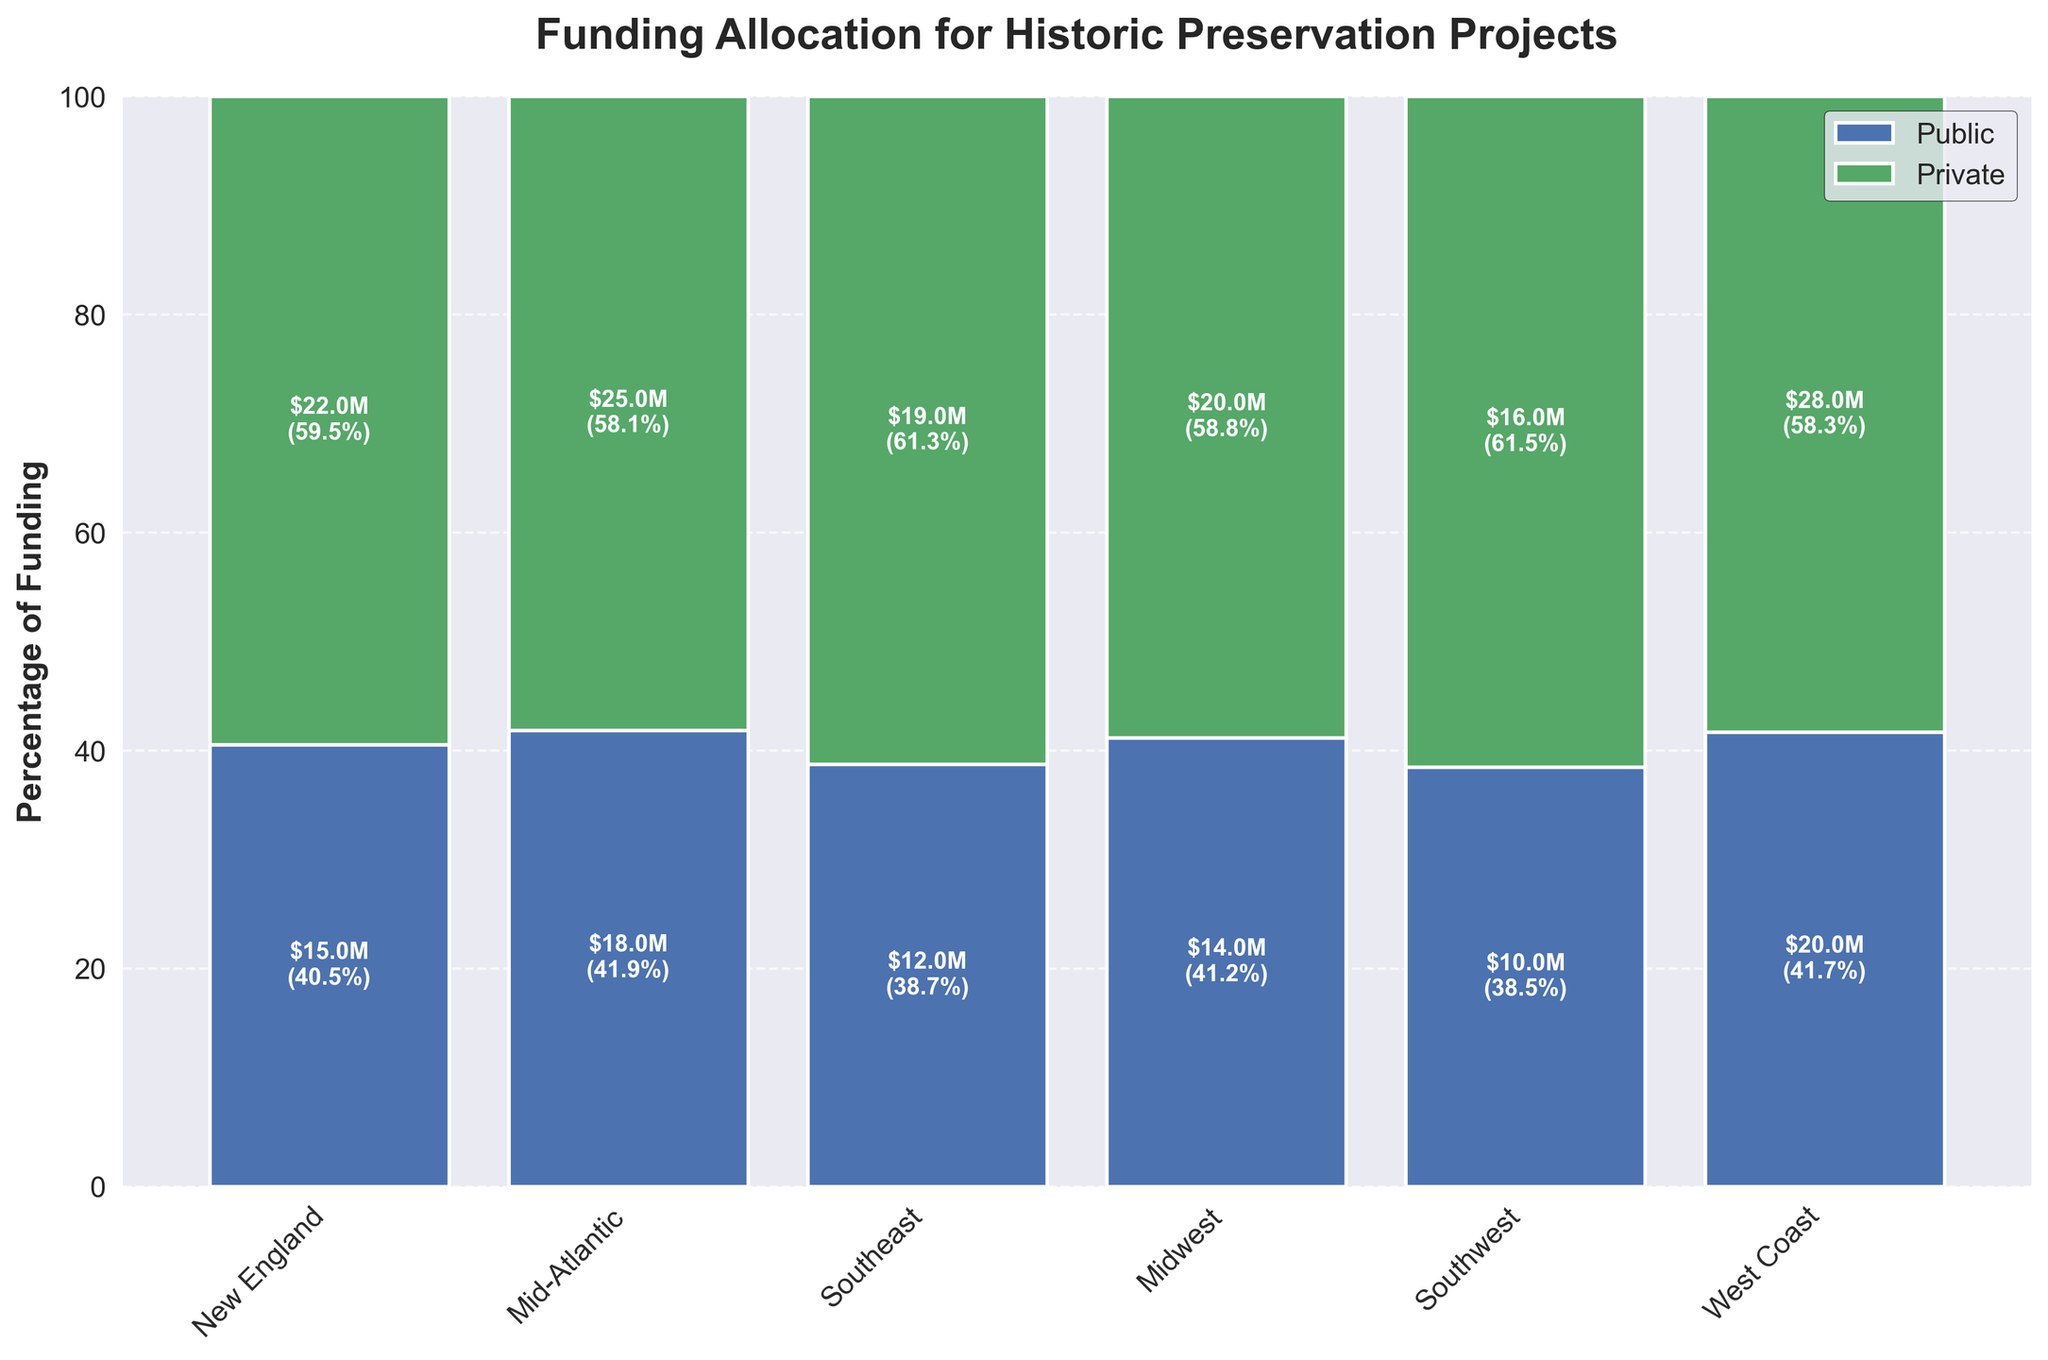What is the title of the figure? It is displayed at the top of the figure.
Answer: Funding Allocation for Historic Preservation Projects In which region is the highest percentage of funding allocated from private sources? Check which region has the tallest green bar segment, which represents private funding.
Answer: West Coast How much public funding (in millions) is allocated for historic preservation projects in New England? Refer to the value labeled within the blue bar segment for New England.
Answer: $15.0M Which region has the least total funding for historic preservation projects? Sum the labeled public and private funding for each region and find the smallest value.
Answer: Southwest What percentage of total funding in the Southeast region comes from private sources? Look at the label in the green bar segment for the Southeast and note the percentage.
Answer: 61.3% How does the total funding in the Midwest compare to the Southwest? Sum the public and private amounts for both regions, then compare the totals. Midwest: $34M, Southwest: $26M
Answer: Midwest has more funding Which region receives more public funding than private funding? Compare the heights of the blue and green bar segments for each region.
Answer: None What is the combined amount of private funding across all regions? Add the private funding values for each region: 22M + 25M + 19M + 20M + 16M + 28M.
Answer: $130M Which region has the narrowest bar in the mosaic plot? The width of the bars represents total funding. The narrowest bar corresponds to the region with the least total funding.
Answer: Southwest Among the regions, which one has the closest distribution of public and private funding percentages? Compare the lengths of the blue and green segments for each region to see which are closest in length.
Answer: Midwest 